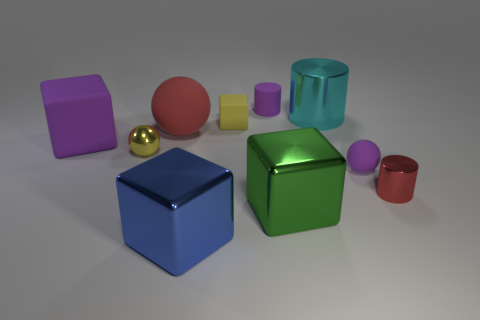There is a tiny ball that is the same color as the tiny rubber cube; what is it made of?
Your response must be concise. Metal. There is a cyan object that is the same size as the green thing; what is it made of?
Provide a short and direct response. Metal. There is a big shiny cube behind the big blue cube; does it have the same color as the large rubber object left of the large red matte sphere?
Provide a succinct answer. No. Are there any yellow metal spheres that are right of the small metal object that is left of the matte cylinder?
Offer a terse response. No. There is a small purple object that is in front of the tiny rubber cube; does it have the same shape as the large metal object that is behind the small red thing?
Provide a short and direct response. No. Is the material of the purple thing behind the yellow matte block the same as the small purple object right of the purple cylinder?
Your response must be concise. Yes. What is the material of the large block on the left side of the big metallic thing in front of the green object?
Ensure brevity in your answer.  Rubber. There is a big shiny object that is behind the rubber object that is left of the shiny thing that is left of the big matte ball; what is its shape?
Provide a short and direct response. Cylinder. What material is the large red object that is the same shape as the yellow metal object?
Offer a terse response. Rubber. How many tiny purple cylinders are there?
Offer a terse response. 1. 